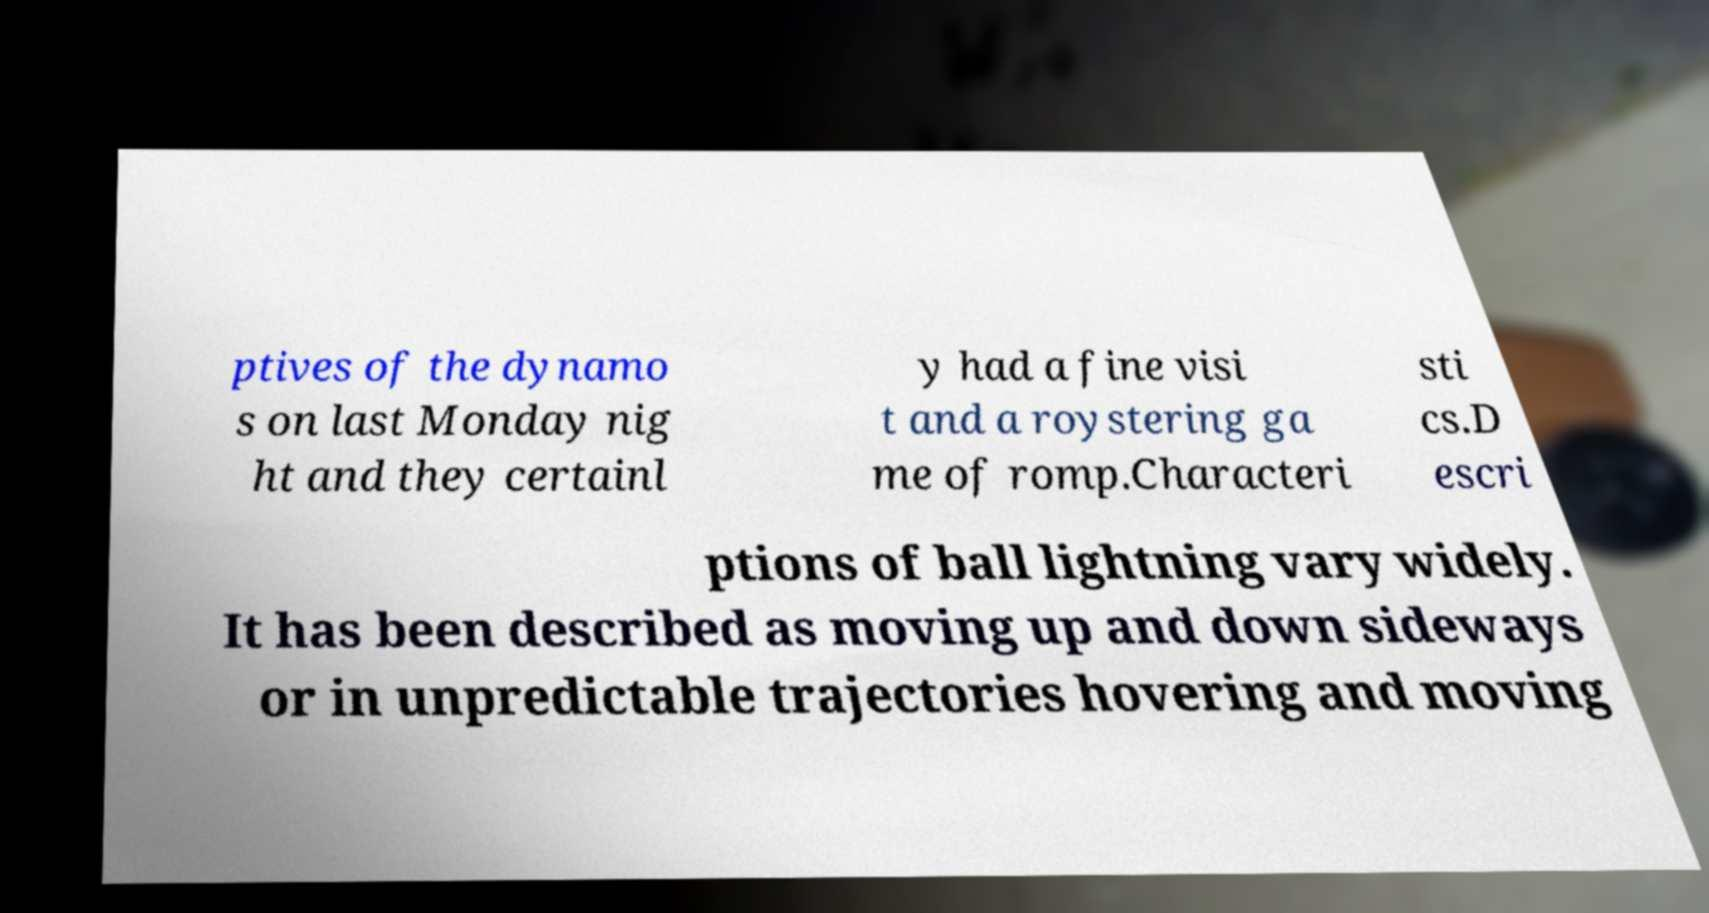What messages or text are displayed in this image? I need them in a readable, typed format. ptives of the dynamo s on last Monday nig ht and they certainl y had a fine visi t and a roystering ga me of romp.Characteri sti cs.D escri ptions of ball lightning vary widely. It has been described as moving up and down sideways or in unpredictable trajectories hovering and moving 